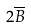<formula> <loc_0><loc_0><loc_500><loc_500>2 \overline { B }</formula> 